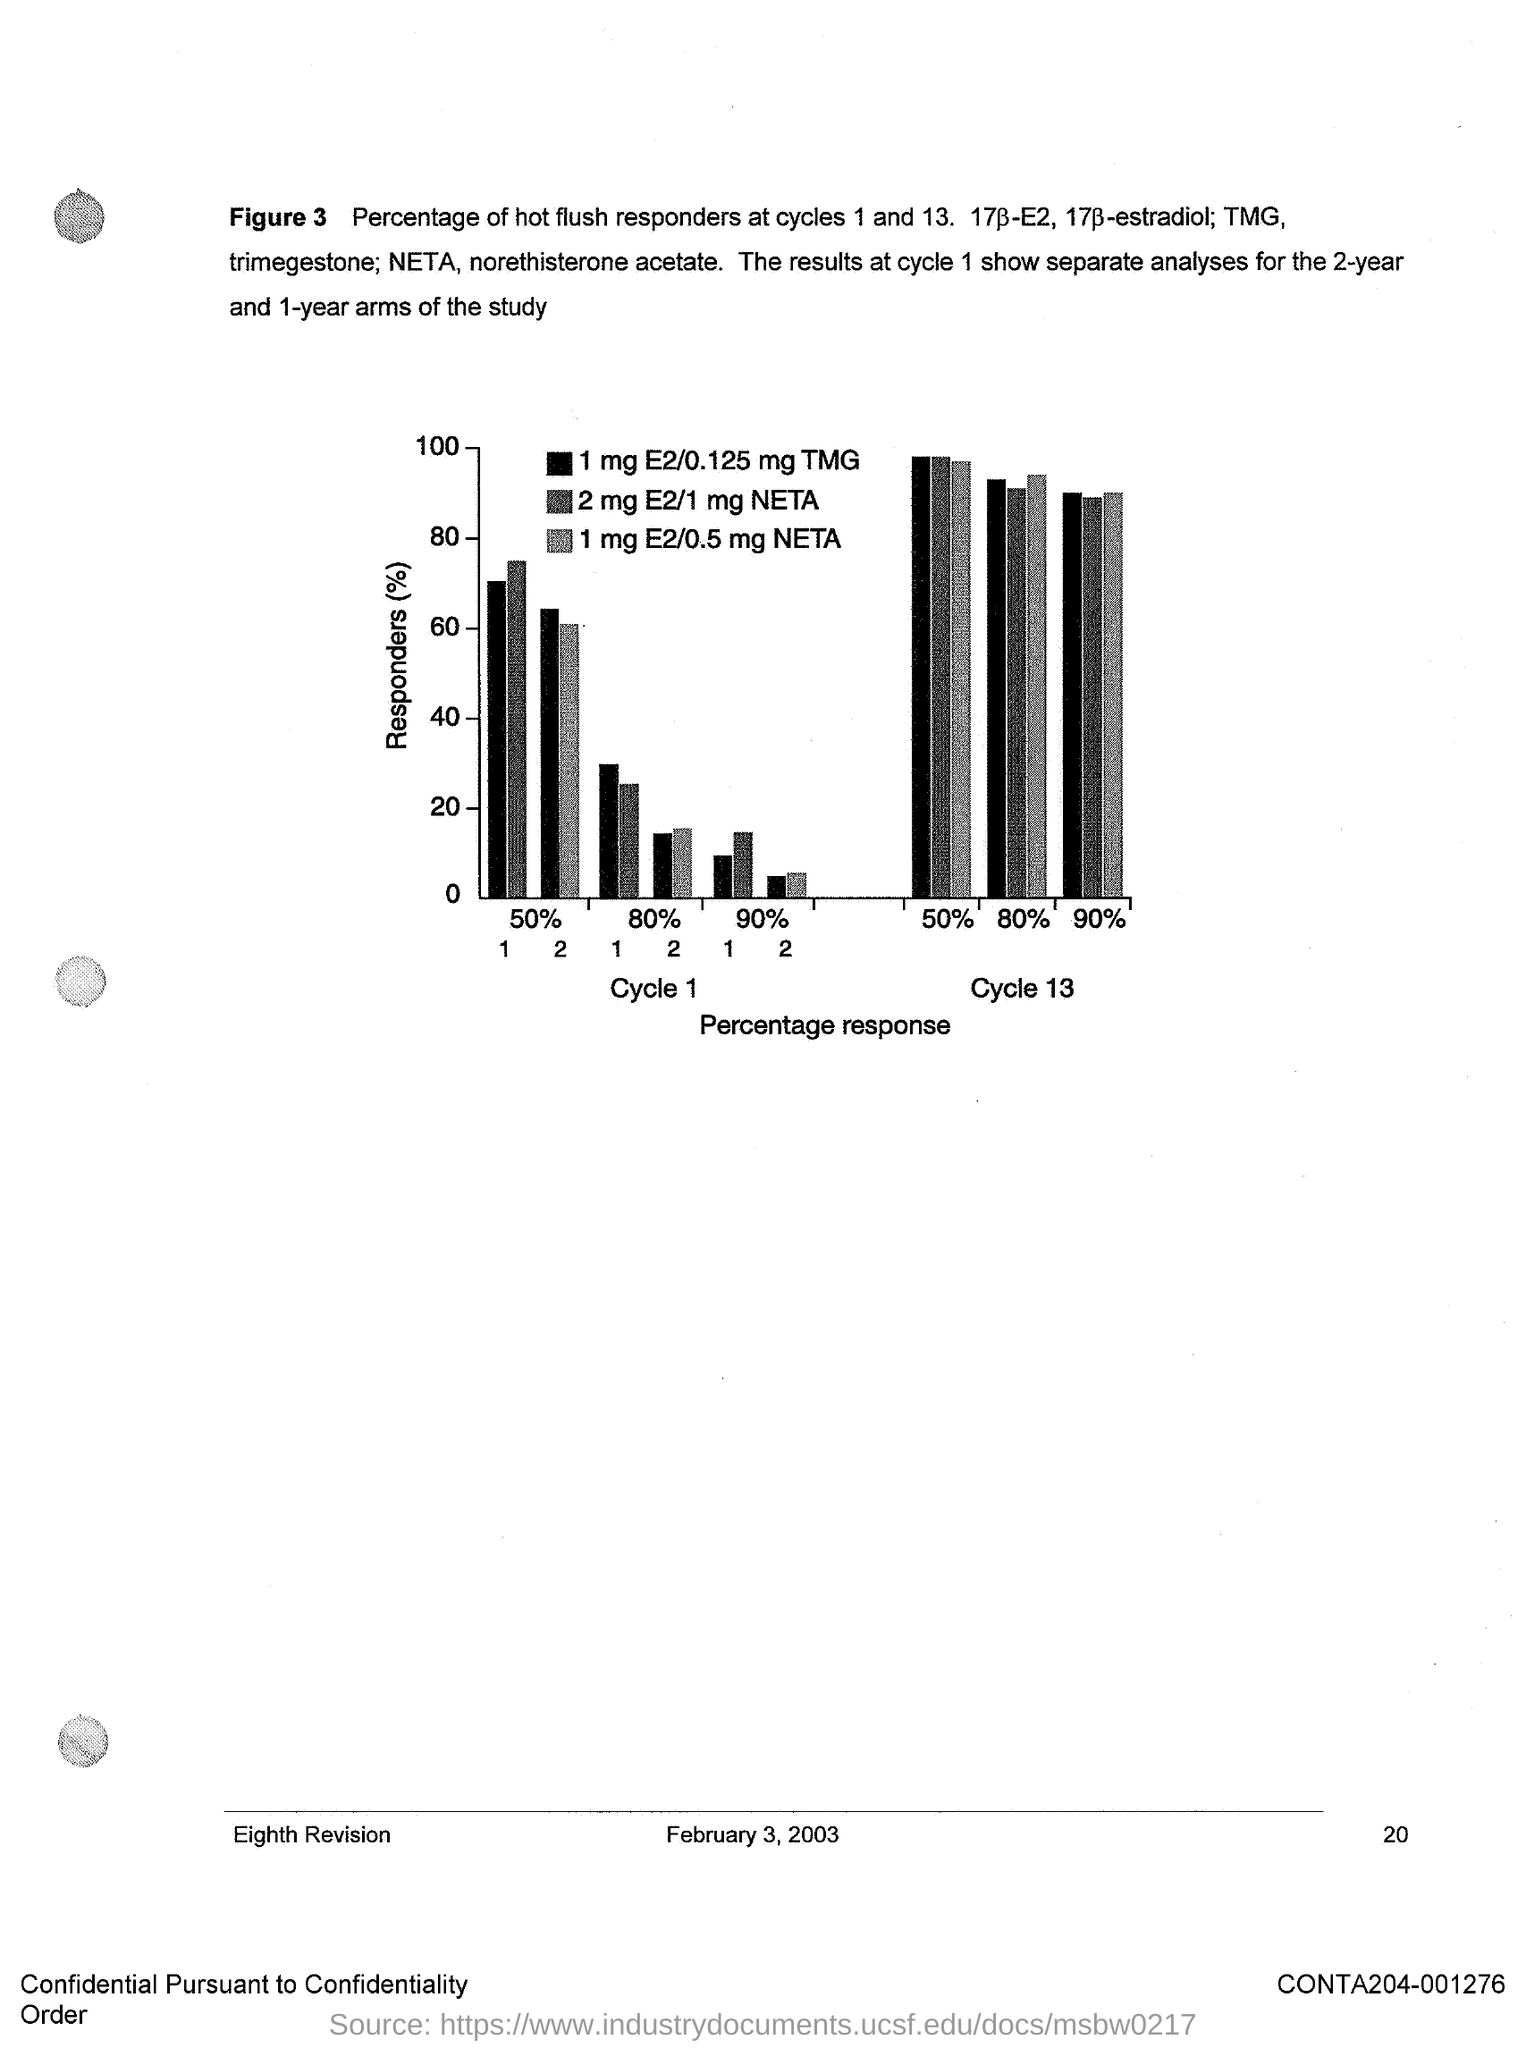What does Figure 3 describe?
Provide a succinct answer. Percentage of hot flush responders at cycles 1 and 13. What does x-axis of the Figure 3 represent?
Your answer should be compact. Percentage response. What does y-axis of the Figure 3 represent?
Offer a very short reply. Responders (%). What is the date mentioned in this document?
Your response must be concise. February 3, 2003. 